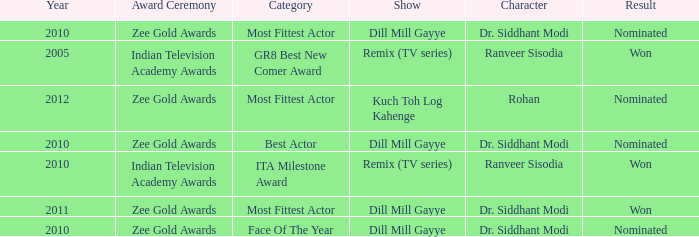Which character was nominated in the 2010 Indian Television Academy Awards? Ranveer Sisodia. 